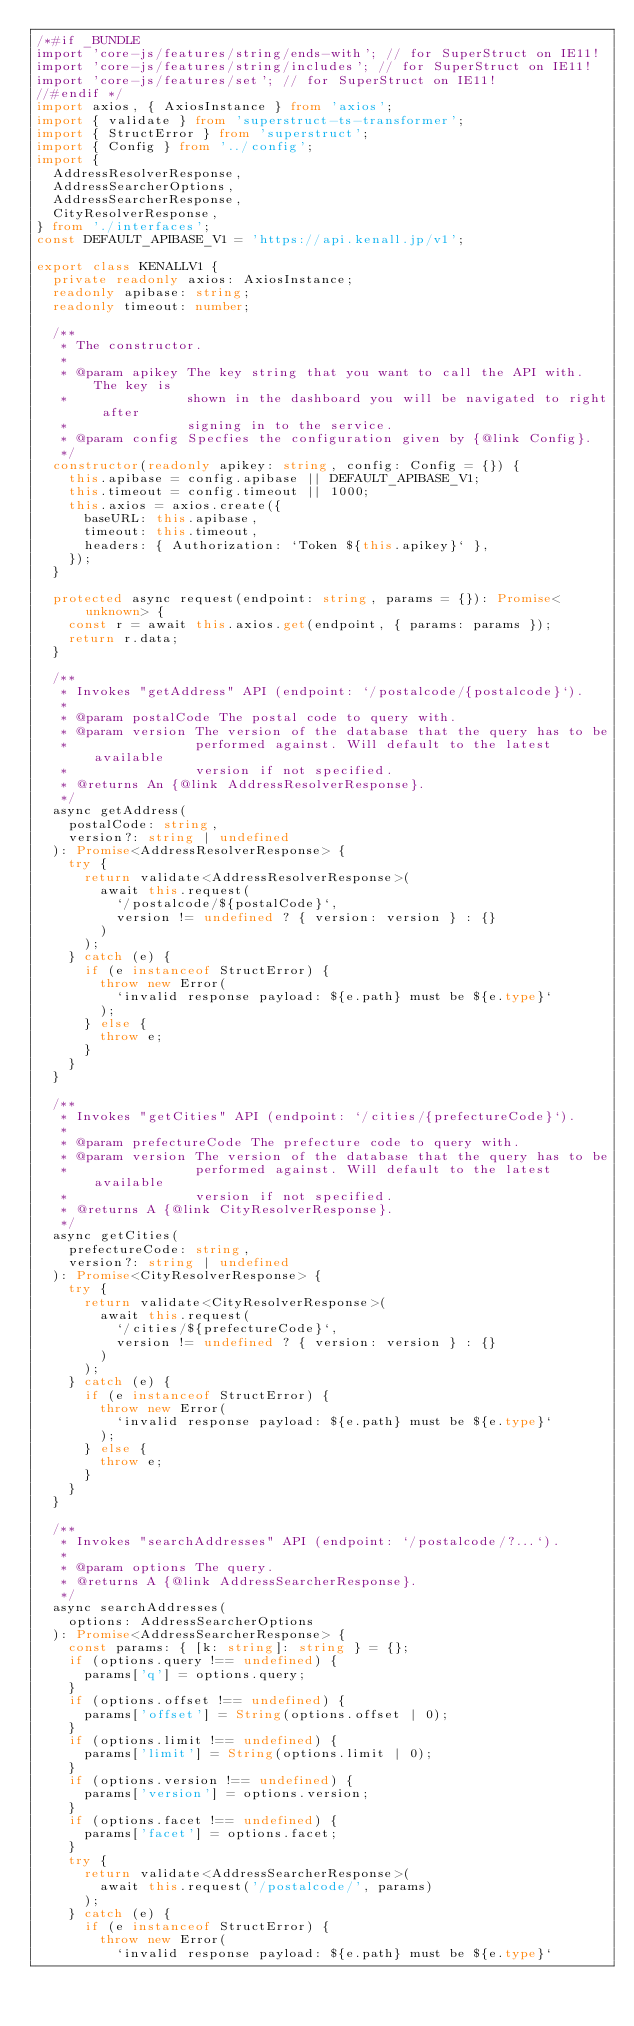<code> <loc_0><loc_0><loc_500><loc_500><_TypeScript_>/*#if _BUNDLE
import 'core-js/features/string/ends-with'; // for SuperStruct on IE11!
import 'core-js/features/string/includes'; // for SuperStruct on IE11!
import 'core-js/features/set'; // for SuperStruct on IE11!
//#endif */
import axios, { AxiosInstance } from 'axios';
import { validate } from 'superstruct-ts-transformer';
import { StructError } from 'superstruct';
import { Config } from '../config';
import {
  AddressResolverResponse,
  AddressSearcherOptions,
  AddressSearcherResponse,
  CityResolverResponse,
} from './interfaces';
const DEFAULT_APIBASE_V1 = 'https://api.kenall.jp/v1';

export class KENALLV1 {
  private readonly axios: AxiosInstance;
  readonly apibase: string;
  readonly timeout: number;

  /**
   * The constructor.
   *
   * @param apikey The key string that you want to call the API with. The key is
   *               shown in the dashboard you will be navigated to right after
   *               signing in to the service.
   * @param config Specfies the configuration given by {@link Config}.
   */
  constructor(readonly apikey: string, config: Config = {}) {
    this.apibase = config.apibase || DEFAULT_APIBASE_V1;
    this.timeout = config.timeout || 1000;
    this.axios = axios.create({
      baseURL: this.apibase,
      timeout: this.timeout,
      headers: { Authorization: `Token ${this.apikey}` },
    });
  }

  protected async request(endpoint: string, params = {}): Promise<unknown> {
    const r = await this.axios.get(endpoint, { params: params });
    return r.data;
  }

  /**
   * Invokes "getAddress" API (endpoint: `/postalcode/{postalcode}`).
   *
   * @param postalCode The postal code to query with.
   * @param version The version of the database that the query has to be
   *                performed against. Will default to the latest available
   *                version if not specified.
   * @returns An {@link AddressResolverResponse}.
   */
  async getAddress(
    postalCode: string,
    version?: string | undefined
  ): Promise<AddressResolverResponse> {
    try {
      return validate<AddressResolverResponse>(
        await this.request(
          `/postalcode/${postalCode}`,
          version != undefined ? { version: version } : {}
        )
      );
    } catch (e) {
      if (e instanceof StructError) {
        throw new Error(
          `invalid response payload: ${e.path} must be ${e.type}`
        );
      } else {
        throw e;
      }
    }
  }

  /**
   * Invokes "getCities" API (endpoint: `/cities/{prefectureCode}`).
   *
   * @param prefectureCode The prefecture code to query with.
   * @param version The version of the database that the query has to be
   *                performed against. Will default to the latest available
   *                version if not specified.
   * @returns A {@link CityResolverResponse}.
   */
  async getCities(
    prefectureCode: string,
    version?: string | undefined
  ): Promise<CityResolverResponse> {
    try {
      return validate<CityResolverResponse>(
        await this.request(
          `/cities/${prefectureCode}`,
          version != undefined ? { version: version } : {}
        )
      );
    } catch (e) {
      if (e instanceof StructError) {
        throw new Error(
          `invalid response payload: ${e.path} must be ${e.type}`
        );
      } else {
        throw e;
      }
    }
  }

  /**
   * Invokes "searchAddresses" API (endpoint: `/postalcode/?...`).
   *
   * @param options The query.
   * @returns A {@link AddressSearcherResponse}.
   */
  async searchAddresses(
    options: AddressSearcherOptions
  ): Promise<AddressSearcherResponse> {
    const params: { [k: string]: string } = {};
    if (options.query !== undefined) {
      params['q'] = options.query;
    }
    if (options.offset !== undefined) {
      params['offset'] = String(options.offset | 0);
    }
    if (options.limit !== undefined) {
      params['limit'] = String(options.limit | 0);
    }
    if (options.version !== undefined) {
      params['version'] = options.version;
    }
    if (options.facet !== undefined) {
      params['facet'] = options.facet;
    }
    try {
      return validate<AddressSearcherResponse>(
        await this.request('/postalcode/', params)
      );
    } catch (e) {
      if (e instanceof StructError) {
        throw new Error(
          `invalid response payload: ${e.path} must be ${e.type}`</code> 